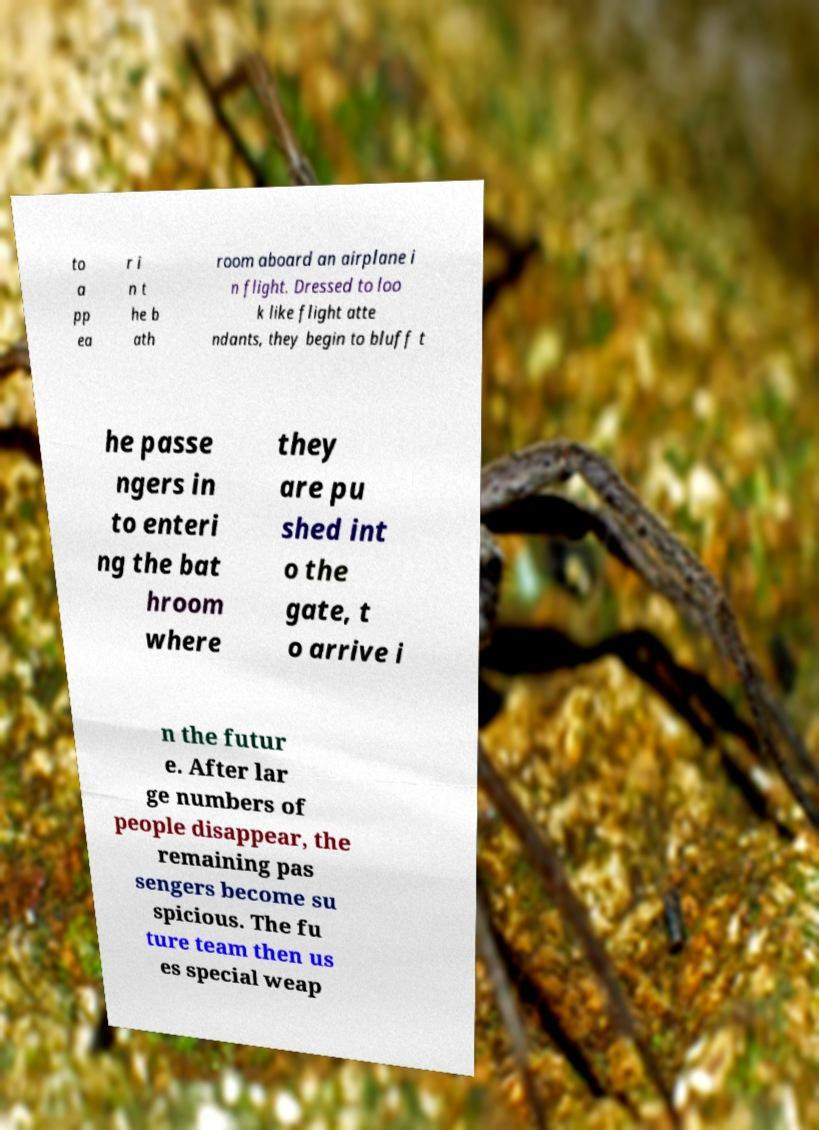Please read and relay the text visible in this image. What does it say? to a pp ea r i n t he b ath room aboard an airplane i n flight. Dressed to loo k like flight atte ndants, they begin to bluff t he passe ngers in to enteri ng the bat hroom where they are pu shed int o the gate, t o arrive i n the futur e. After lar ge numbers of people disappear, the remaining pas sengers become su spicious. The fu ture team then us es special weap 